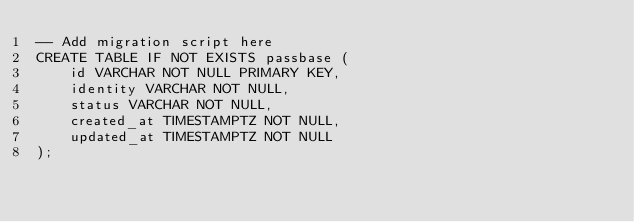Convert code to text. <code><loc_0><loc_0><loc_500><loc_500><_SQL_>-- Add migration script here
CREATE TABLE IF NOT EXISTS passbase (
    id VARCHAR NOT NULL PRIMARY KEY,
    identity VARCHAR NOT NULL,
    status VARCHAR NOT NULL,
    created_at TIMESTAMPTZ NOT NULL,
    updated_at TIMESTAMPTZ NOT NULL
);</code> 